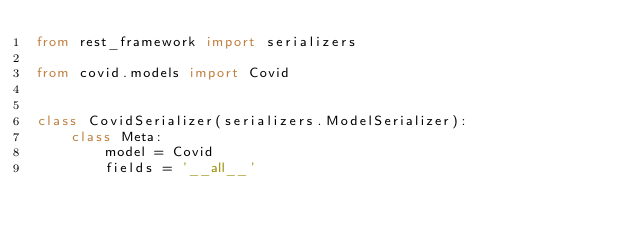<code> <loc_0><loc_0><loc_500><loc_500><_Python_>from rest_framework import serializers

from covid.models import Covid


class CovidSerializer(serializers.ModelSerializer):
    class Meta:
        model = Covid
        fields = '__all__'
</code> 